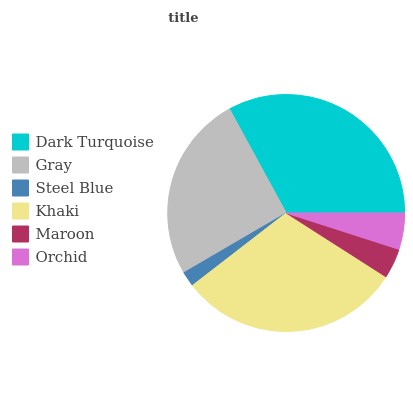Is Steel Blue the minimum?
Answer yes or no. Yes. Is Dark Turquoise the maximum?
Answer yes or no. Yes. Is Gray the minimum?
Answer yes or no. No. Is Gray the maximum?
Answer yes or no. No. Is Dark Turquoise greater than Gray?
Answer yes or no. Yes. Is Gray less than Dark Turquoise?
Answer yes or no. Yes. Is Gray greater than Dark Turquoise?
Answer yes or no. No. Is Dark Turquoise less than Gray?
Answer yes or no. No. Is Gray the high median?
Answer yes or no. Yes. Is Orchid the low median?
Answer yes or no. Yes. Is Orchid the high median?
Answer yes or no. No. Is Gray the low median?
Answer yes or no. No. 